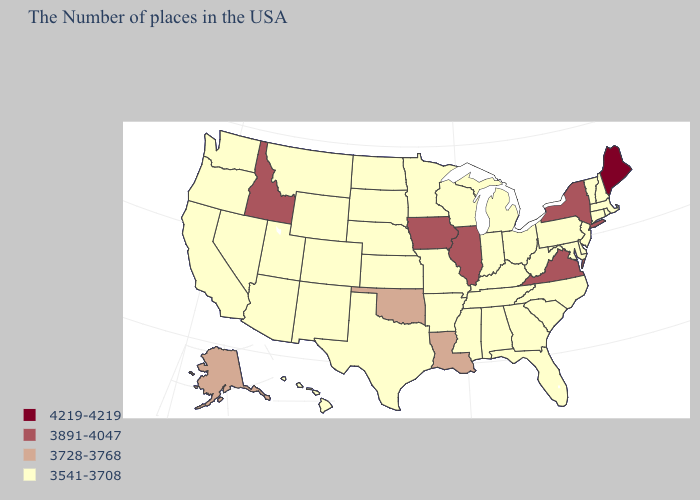Does Hawaii have the lowest value in the USA?
Write a very short answer. Yes. Name the states that have a value in the range 3541-3708?
Write a very short answer. Massachusetts, Rhode Island, New Hampshire, Vermont, Connecticut, New Jersey, Delaware, Maryland, Pennsylvania, North Carolina, South Carolina, West Virginia, Ohio, Florida, Georgia, Michigan, Kentucky, Indiana, Alabama, Tennessee, Wisconsin, Mississippi, Missouri, Arkansas, Minnesota, Kansas, Nebraska, Texas, South Dakota, North Dakota, Wyoming, Colorado, New Mexico, Utah, Montana, Arizona, Nevada, California, Washington, Oregon, Hawaii. What is the lowest value in the USA?
Write a very short answer. 3541-3708. Does South Carolina have a lower value than Oklahoma?
Write a very short answer. Yes. Does Alaska have a higher value than Idaho?
Give a very brief answer. No. Name the states that have a value in the range 4219-4219?
Write a very short answer. Maine. How many symbols are there in the legend?
Concise answer only. 4. Which states have the highest value in the USA?
Concise answer only. Maine. Does Maine have the same value as Ohio?
Keep it brief. No. Does Florida have the lowest value in the South?
Answer briefly. Yes. What is the value of Alabama?
Concise answer only. 3541-3708. Name the states that have a value in the range 3541-3708?
Concise answer only. Massachusetts, Rhode Island, New Hampshire, Vermont, Connecticut, New Jersey, Delaware, Maryland, Pennsylvania, North Carolina, South Carolina, West Virginia, Ohio, Florida, Georgia, Michigan, Kentucky, Indiana, Alabama, Tennessee, Wisconsin, Mississippi, Missouri, Arkansas, Minnesota, Kansas, Nebraska, Texas, South Dakota, North Dakota, Wyoming, Colorado, New Mexico, Utah, Montana, Arizona, Nevada, California, Washington, Oregon, Hawaii. Does Delaware have the highest value in the USA?
Quick response, please. No. 